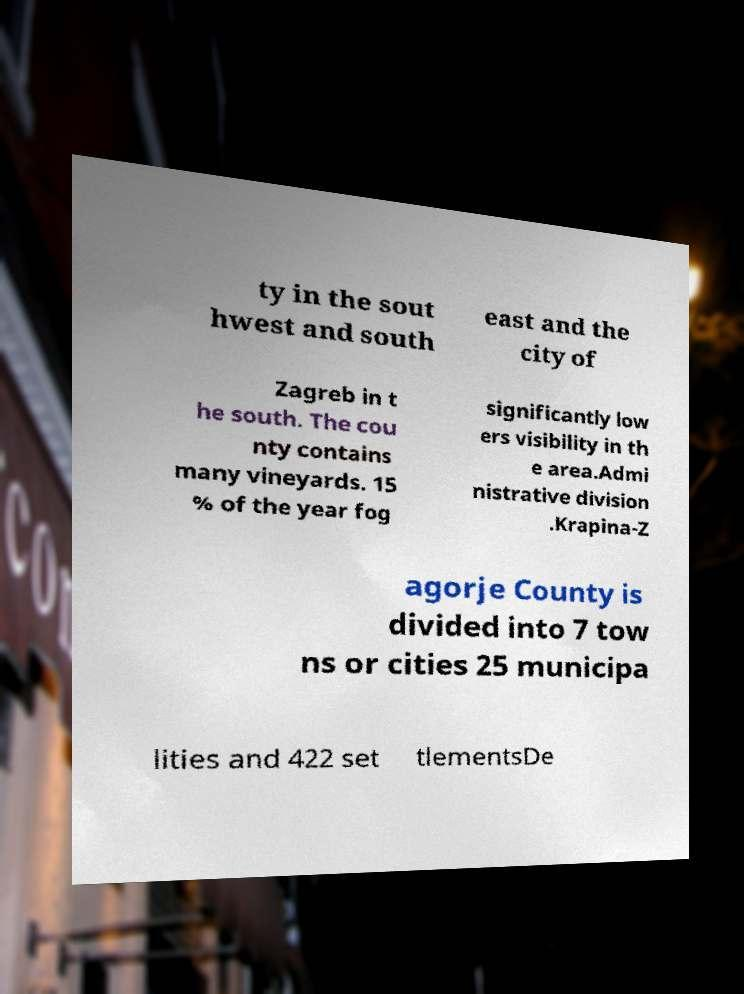Could you assist in decoding the text presented in this image and type it out clearly? ty in the sout hwest and south east and the city of Zagreb in t he south. The cou nty contains many vineyards. 15 % of the year fog significantly low ers visibility in th e area.Admi nistrative division .Krapina-Z agorje County is divided into 7 tow ns or cities 25 municipa lities and 422 set tlementsDe 